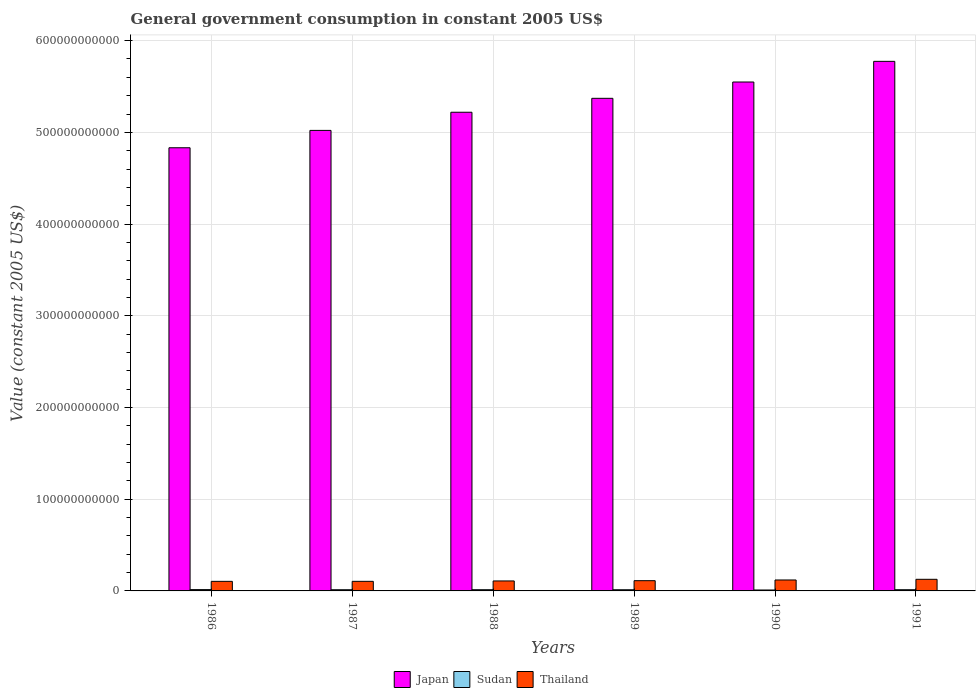How many different coloured bars are there?
Keep it short and to the point. 3. Are the number of bars per tick equal to the number of legend labels?
Your answer should be compact. Yes. How many bars are there on the 1st tick from the right?
Your answer should be compact. 3. In how many cases, is the number of bars for a given year not equal to the number of legend labels?
Ensure brevity in your answer.  0. What is the government conusmption in Thailand in 1987?
Provide a succinct answer. 1.05e+1. Across all years, what is the maximum government conusmption in Sudan?
Your answer should be compact. 1.44e+09. Across all years, what is the minimum government conusmption in Sudan?
Your answer should be very brief. 1.02e+09. In which year was the government conusmption in Thailand minimum?
Provide a succinct answer. 1986. What is the total government conusmption in Japan in the graph?
Your answer should be compact. 3.18e+12. What is the difference between the government conusmption in Sudan in 1987 and that in 1990?
Offer a very short reply. 2.80e+08. What is the difference between the government conusmption in Sudan in 1989 and the government conusmption in Japan in 1991?
Offer a very short reply. -5.76e+11. What is the average government conusmption in Thailand per year?
Provide a short and direct response. 1.13e+1. In the year 1986, what is the difference between the government conusmption in Sudan and government conusmption in Japan?
Provide a succinct answer. -4.82e+11. In how many years, is the government conusmption in Japan greater than 420000000000 US$?
Give a very brief answer. 6. What is the ratio of the government conusmption in Thailand in 1988 to that in 1990?
Your answer should be very brief. 0.91. Is the government conusmption in Japan in 1989 less than that in 1991?
Give a very brief answer. Yes. What is the difference between the highest and the second highest government conusmption in Thailand?
Offer a very short reply. 7.39e+08. What is the difference between the highest and the lowest government conusmption in Japan?
Your response must be concise. 9.42e+1. In how many years, is the government conusmption in Thailand greater than the average government conusmption in Thailand taken over all years?
Your answer should be compact. 2. What does the 3rd bar from the right in 1990 represents?
Make the answer very short. Japan. How many years are there in the graph?
Keep it short and to the point. 6. What is the difference between two consecutive major ticks on the Y-axis?
Provide a short and direct response. 1.00e+11. Are the values on the major ticks of Y-axis written in scientific E-notation?
Provide a short and direct response. No. Does the graph contain any zero values?
Provide a short and direct response. No. Where does the legend appear in the graph?
Provide a succinct answer. Bottom center. How are the legend labels stacked?
Offer a very short reply. Horizontal. What is the title of the graph?
Your answer should be compact. General government consumption in constant 2005 US$. Does "Gabon" appear as one of the legend labels in the graph?
Keep it short and to the point. No. What is the label or title of the Y-axis?
Offer a very short reply. Value (constant 2005 US$). What is the Value (constant 2005 US$) of Japan in 1986?
Your answer should be very brief. 4.83e+11. What is the Value (constant 2005 US$) in Sudan in 1986?
Your answer should be very brief. 1.44e+09. What is the Value (constant 2005 US$) of Thailand in 1986?
Ensure brevity in your answer.  1.04e+1. What is the Value (constant 2005 US$) of Japan in 1987?
Your answer should be very brief. 5.02e+11. What is the Value (constant 2005 US$) in Sudan in 1987?
Provide a succinct answer. 1.30e+09. What is the Value (constant 2005 US$) in Thailand in 1987?
Give a very brief answer. 1.05e+1. What is the Value (constant 2005 US$) in Japan in 1988?
Ensure brevity in your answer.  5.22e+11. What is the Value (constant 2005 US$) in Sudan in 1988?
Offer a very short reply. 1.32e+09. What is the Value (constant 2005 US$) in Thailand in 1988?
Your answer should be very brief. 1.09e+1. What is the Value (constant 2005 US$) of Japan in 1989?
Provide a short and direct response. 5.37e+11. What is the Value (constant 2005 US$) of Sudan in 1989?
Give a very brief answer. 1.29e+09. What is the Value (constant 2005 US$) in Thailand in 1989?
Your answer should be very brief. 1.12e+1. What is the Value (constant 2005 US$) of Japan in 1990?
Ensure brevity in your answer.  5.55e+11. What is the Value (constant 2005 US$) in Sudan in 1990?
Provide a succinct answer. 1.02e+09. What is the Value (constant 2005 US$) of Thailand in 1990?
Make the answer very short. 1.19e+1. What is the Value (constant 2005 US$) in Japan in 1991?
Make the answer very short. 5.77e+11. What is the Value (constant 2005 US$) of Sudan in 1991?
Offer a very short reply. 1.32e+09. What is the Value (constant 2005 US$) of Thailand in 1991?
Make the answer very short. 1.27e+1. Across all years, what is the maximum Value (constant 2005 US$) in Japan?
Provide a short and direct response. 5.77e+11. Across all years, what is the maximum Value (constant 2005 US$) in Sudan?
Provide a short and direct response. 1.44e+09. Across all years, what is the maximum Value (constant 2005 US$) of Thailand?
Make the answer very short. 1.27e+1. Across all years, what is the minimum Value (constant 2005 US$) in Japan?
Provide a short and direct response. 4.83e+11. Across all years, what is the minimum Value (constant 2005 US$) in Sudan?
Make the answer very short. 1.02e+09. Across all years, what is the minimum Value (constant 2005 US$) in Thailand?
Keep it short and to the point. 1.04e+1. What is the total Value (constant 2005 US$) of Japan in the graph?
Make the answer very short. 3.18e+12. What is the total Value (constant 2005 US$) of Sudan in the graph?
Keep it short and to the point. 7.68e+09. What is the total Value (constant 2005 US$) in Thailand in the graph?
Give a very brief answer. 6.75e+1. What is the difference between the Value (constant 2005 US$) in Japan in 1986 and that in 1987?
Your answer should be very brief. -1.89e+1. What is the difference between the Value (constant 2005 US$) of Sudan in 1986 and that in 1987?
Make the answer very short. 1.37e+08. What is the difference between the Value (constant 2005 US$) in Thailand in 1986 and that in 1987?
Your response must be concise. -2.98e+07. What is the difference between the Value (constant 2005 US$) of Japan in 1986 and that in 1988?
Your answer should be very brief. -3.87e+1. What is the difference between the Value (constant 2005 US$) in Sudan in 1986 and that in 1988?
Your response must be concise. 1.16e+08. What is the difference between the Value (constant 2005 US$) in Thailand in 1986 and that in 1988?
Offer a terse response. -4.51e+08. What is the difference between the Value (constant 2005 US$) of Japan in 1986 and that in 1989?
Keep it short and to the point. -5.39e+1. What is the difference between the Value (constant 2005 US$) in Sudan in 1986 and that in 1989?
Give a very brief answer. 1.50e+08. What is the difference between the Value (constant 2005 US$) in Thailand in 1986 and that in 1989?
Ensure brevity in your answer.  -7.37e+08. What is the difference between the Value (constant 2005 US$) in Japan in 1986 and that in 1990?
Make the answer very short. -7.17e+1. What is the difference between the Value (constant 2005 US$) in Sudan in 1986 and that in 1990?
Offer a terse response. 4.17e+08. What is the difference between the Value (constant 2005 US$) in Thailand in 1986 and that in 1990?
Provide a succinct answer. -1.51e+09. What is the difference between the Value (constant 2005 US$) in Japan in 1986 and that in 1991?
Your answer should be very brief. -9.42e+1. What is the difference between the Value (constant 2005 US$) of Sudan in 1986 and that in 1991?
Ensure brevity in your answer.  1.16e+08. What is the difference between the Value (constant 2005 US$) of Thailand in 1986 and that in 1991?
Your response must be concise. -2.25e+09. What is the difference between the Value (constant 2005 US$) of Japan in 1987 and that in 1988?
Your response must be concise. -1.98e+1. What is the difference between the Value (constant 2005 US$) of Sudan in 1987 and that in 1988?
Give a very brief answer. -2.08e+07. What is the difference between the Value (constant 2005 US$) in Thailand in 1987 and that in 1988?
Give a very brief answer. -4.22e+08. What is the difference between the Value (constant 2005 US$) in Japan in 1987 and that in 1989?
Your answer should be compact. -3.50e+1. What is the difference between the Value (constant 2005 US$) in Sudan in 1987 and that in 1989?
Your answer should be very brief. 1.28e+07. What is the difference between the Value (constant 2005 US$) in Thailand in 1987 and that in 1989?
Your answer should be very brief. -7.07e+08. What is the difference between the Value (constant 2005 US$) in Japan in 1987 and that in 1990?
Provide a succinct answer. -5.28e+1. What is the difference between the Value (constant 2005 US$) in Sudan in 1987 and that in 1990?
Provide a short and direct response. 2.80e+08. What is the difference between the Value (constant 2005 US$) in Thailand in 1987 and that in 1990?
Offer a very short reply. -1.48e+09. What is the difference between the Value (constant 2005 US$) of Japan in 1987 and that in 1991?
Your response must be concise. -7.53e+1. What is the difference between the Value (constant 2005 US$) in Sudan in 1987 and that in 1991?
Offer a very short reply. -2.11e+07. What is the difference between the Value (constant 2005 US$) of Thailand in 1987 and that in 1991?
Your response must be concise. -2.22e+09. What is the difference between the Value (constant 2005 US$) in Japan in 1988 and that in 1989?
Your response must be concise. -1.52e+1. What is the difference between the Value (constant 2005 US$) of Sudan in 1988 and that in 1989?
Offer a very short reply. 3.36e+07. What is the difference between the Value (constant 2005 US$) of Thailand in 1988 and that in 1989?
Make the answer very short. -2.85e+08. What is the difference between the Value (constant 2005 US$) in Japan in 1988 and that in 1990?
Provide a short and direct response. -3.30e+1. What is the difference between the Value (constant 2005 US$) of Sudan in 1988 and that in 1990?
Your response must be concise. 3.01e+08. What is the difference between the Value (constant 2005 US$) of Thailand in 1988 and that in 1990?
Offer a terse response. -1.06e+09. What is the difference between the Value (constant 2005 US$) in Japan in 1988 and that in 1991?
Your response must be concise. -5.55e+1. What is the difference between the Value (constant 2005 US$) in Sudan in 1988 and that in 1991?
Your answer should be compact. -2.87e+05. What is the difference between the Value (constant 2005 US$) in Thailand in 1988 and that in 1991?
Your response must be concise. -1.80e+09. What is the difference between the Value (constant 2005 US$) of Japan in 1989 and that in 1990?
Your answer should be very brief. -1.78e+1. What is the difference between the Value (constant 2005 US$) in Sudan in 1989 and that in 1990?
Keep it short and to the point. 2.67e+08. What is the difference between the Value (constant 2005 US$) in Thailand in 1989 and that in 1990?
Make the answer very short. -7.72e+08. What is the difference between the Value (constant 2005 US$) in Japan in 1989 and that in 1991?
Keep it short and to the point. -4.03e+1. What is the difference between the Value (constant 2005 US$) in Sudan in 1989 and that in 1991?
Provide a short and direct response. -3.38e+07. What is the difference between the Value (constant 2005 US$) in Thailand in 1989 and that in 1991?
Your response must be concise. -1.51e+09. What is the difference between the Value (constant 2005 US$) of Japan in 1990 and that in 1991?
Your answer should be compact. -2.25e+1. What is the difference between the Value (constant 2005 US$) in Sudan in 1990 and that in 1991?
Provide a short and direct response. -3.01e+08. What is the difference between the Value (constant 2005 US$) in Thailand in 1990 and that in 1991?
Your answer should be very brief. -7.39e+08. What is the difference between the Value (constant 2005 US$) in Japan in 1986 and the Value (constant 2005 US$) in Sudan in 1987?
Keep it short and to the point. 4.82e+11. What is the difference between the Value (constant 2005 US$) of Japan in 1986 and the Value (constant 2005 US$) of Thailand in 1987?
Ensure brevity in your answer.  4.73e+11. What is the difference between the Value (constant 2005 US$) of Sudan in 1986 and the Value (constant 2005 US$) of Thailand in 1987?
Keep it short and to the point. -9.02e+09. What is the difference between the Value (constant 2005 US$) of Japan in 1986 and the Value (constant 2005 US$) of Sudan in 1988?
Give a very brief answer. 4.82e+11. What is the difference between the Value (constant 2005 US$) in Japan in 1986 and the Value (constant 2005 US$) in Thailand in 1988?
Provide a succinct answer. 4.72e+11. What is the difference between the Value (constant 2005 US$) in Sudan in 1986 and the Value (constant 2005 US$) in Thailand in 1988?
Offer a very short reply. -9.44e+09. What is the difference between the Value (constant 2005 US$) of Japan in 1986 and the Value (constant 2005 US$) of Sudan in 1989?
Keep it short and to the point. 4.82e+11. What is the difference between the Value (constant 2005 US$) in Japan in 1986 and the Value (constant 2005 US$) in Thailand in 1989?
Make the answer very short. 4.72e+11. What is the difference between the Value (constant 2005 US$) in Sudan in 1986 and the Value (constant 2005 US$) in Thailand in 1989?
Make the answer very short. -9.73e+09. What is the difference between the Value (constant 2005 US$) in Japan in 1986 and the Value (constant 2005 US$) in Sudan in 1990?
Offer a terse response. 4.82e+11. What is the difference between the Value (constant 2005 US$) in Japan in 1986 and the Value (constant 2005 US$) in Thailand in 1990?
Your response must be concise. 4.71e+11. What is the difference between the Value (constant 2005 US$) in Sudan in 1986 and the Value (constant 2005 US$) in Thailand in 1990?
Make the answer very short. -1.05e+1. What is the difference between the Value (constant 2005 US$) of Japan in 1986 and the Value (constant 2005 US$) of Sudan in 1991?
Keep it short and to the point. 4.82e+11. What is the difference between the Value (constant 2005 US$) of Japan in 1986 and the Value (constant 2005 US$) of Thailand in 1991?
Offer a terse response. 4.71e+11. What is the difference between the Value (constant 2005 US$) of Sudan in 1986 and the Value (constant 2005 US$) of Thailand in 1991?
Your response must be concise. -1.12e+1. What is the difference between the Value (constant 2005 US$) of Japan in 1987 and the Value (constant 2005 US$) of Sudan in 1988?
Ensure brevity in your answer.  5.01e+11. What is the difference between the Value (constant 2005 US$) in Japan in 1987 and the Value (constant 2005 US$) in Thailand in 1988?
Ensure brevity in your answer.  4.91e+11. What is the difference between the Value (constant 2005 US$) of Sudan in 1987 and the Value (constant 2005 US$) of Thailand in 1988?
Give a very brief answer. -9.58e+09. What is the difference between the Value (constant 2005 US$) of Japan in 1987 and the Value (constant 2005 US$) of Sudan in 1989?
Ensure brevity in your answer.  5.01e+11. What is the difference between the Value (constant 2005 US$) in Japan in 1987 and the Value (constant 2005 US$) in Thailand in 1989?
Offer a terse response. 4.91e+11. What is the difference between the Value (constant 2005 US$) in Sudan in 1987 and the Value (constant 2005 US$) in Thailand in 1989?
Your answer should be compact. -9.86e+09. What is the difference between the Value (constant 2005 US$) in Japan in 1987 and the Value (constant 2005 US$) in Sudan in 1990?
Provide a succinct answer. 5.01e+11. What is the difference between the Value (constant 2005 US$) of Japan in 1987 and the Value (constant 2005 US$) of Thailand in 1990?
Make the answer very short. 4.90e+11. What is the difference between the Value (constant 2005 US$) of Sudan in 1987 and the Value (constant 2005 US$) of Thailand in 1990?
Your answer should be compact. -1.06e+1. What is the difference between the Value (constant 2005 US$) of Japan in 1987 and the Value (constant 2005 US$) of Sudan in 1991?
Offer a terse response. 5.01e+11. What is the difference between the Value (constant 2005 US$) in Japan in 1987 and the Value (constant 2005 US$) in Thailand in 1991?
Provide a short and direct response. 4.89e+11. What is the difference between the Value (constant 2005 US$) of Sudan in 1987 and the Value (constant 2005 US$) of Thailand in 1991?
Provide a succinct answer. -1.14e+1. What is the difference between the Value (constant 2005 US$) in Japan in 1988 and the Value (constant 2005 US$) in Sudan in 1989?
Give a very brief answer. 5.21e+11. What is the difference between the Value (constant 2005 US$) in Japan in 1988 and the Value (constant 2005 US$) in Thailand in 1989?
Provide a succinct answer. 5.11e+11. What is the difference between the Value (constant 2005 US$) in Sudan in 1988 and the Value (constant 2005 US$) in Thailand in 1989?
Your answer should be very brief. -9.84e+09. What is the difference between the Value (constant 2005 US$) of Japan in 1988 and the Value (constant 2005 US$) of Sudan in 1990?
Make the answer very short. 5.21e+11. What is the difference between the Value (constant 2005 US$) in Japan in 1988 and the Value (constant 2005 US$) in Thailand in 1990?
Make the answer very short. 5.10e+11. What is the difference between the Value (constant 2005 US$) in Sudan in 1988 and the Value (constant 2005 US$) in Thailand in 1990?
Keep it short and to the point. -1.06e+1. What is the difference between the Value (constant 2005 US$) of Japan in 1988 and the Value (constant 2005 US$) of Sudan in 1991?
Give a very brief answer. 5.21e+11. What is the difference between the Value (constant 2005 US$) of Japan in 1988 and the Value (constant 2005 US$) of Thailand in 1991?
Provide a succinct answer. 5.09e+11. What is the difference between the Value (constant 2005 US$) of Sudan in 1988 and the Value (constant 2005 US$) of Thailand in 1991?
Offer a terse response. -1.14e+1. What is the difference between the Value (constant 2005 US$) of Japan in 1989 and the Value (constant 2005 US$) of Sudan in 1990?
Provide a succinct answer. 5.36e+11. What is the difference between the Value (constant 2005 US$) in Japan in 1989 and the Value (constant 2005 US$) in Thailand in 1990?
Keep it short and to the point. 5.25e+11. What is the difference between the Value (constant 2005 US$) in Sudan in 1989 and the Value (constant 2005 US$) in Thailand in 1990?
Keep it short and to the point. -1.06e+1. What is the difference between the Value (constant 2005 US$) in Japan in 1989 and the Value (constant 2005 US$) in Sudan in 1991?
Your answer should be compact. 5.36e+11. What is the difference between the Value (constant 2005 US$) in Japan in 1989 and the Value (constant 2005 US$) in Thailand in 1991?
Ensure brevity in your answer.  5.24e+11. What is the difference between the Value (constant 2005 US$) of Sudan in 1989 and the Value (constant 2005 US$) of Thailand in 1991?
Offer a terse response. -1.14e+1. What is the difference between the Value (constant 2005 US$) of Japan in 1990 and the Value (constant 2005 US$) of Sudan in 1991?
Make the answer very short. 5.54e+11. What is the difference between the Value (constant 2005 US$) of Japan in 1990 and the Value (constant 2005 US$) of Thailand in 1991?
Provide a short and direct response. 5.42e+11. What is the difference between the Value (constant 2005 US$) in Sudan in 1990 and the Value (constant 2005 US$) in Thailand in 1991?
Keep it short and to the point. -1.17e+1. What is the average Value (constant 2005 US$) in Japan per year?
Your answer should be compact. 5.29e+11. What is the average Value (constant 2005 US$) in Sudan per year?
Your response must be concise. 1.28e+09. What is the average Value (constant 2005 US$) of Thailand per year?
Keep it short and to the point. 1.13e+1. In the year 1986, what is the difference between the Value (constant 2005 US$) of Japan and Value (constant 2005 US$) of Sudan?
Keep it short and to the point. 4.82e+11. In the year 1986, what is the difference between the Value (constant 2005 US$) of Japan and Value (constant 2005 US$) of Thailand?
Your answer should be compact. 4.73e+11. In the year 1986, what is the difference between the Value (constant 2005 US$) in Sudan and Value (constant 2005 US$) in Thailand?
Give a very brief answer. -8.99e+09. In the year 1987, what is the difference between the Value (constant 2005 US$) in Japan and Value (constant 2005 US$) in Sudan?
Make the answer very short. 5.01e+11. In the year 1987, what is the difference between the Value (constant 2005 US$) in Japan and Value (constant 2005 US$) in Thailand?
Provide a short and direct response. 4.92e+11. In the year 1987, what is the difference between the Value (constant 2005 US$) in Sudan and Value (constant 2005 US$) in Thailand?
Give a very brief answer. -9.16e+09. In the year 1988, what is the difference between the Value (constant 2005 US$) in Japan and Value (constant 2005 US$) in Sudan?
Your answer should be very brief. 5.21e+11. In the year 1988, what is the difference between the Value (constant 2005 US$) of Japan and Value (constant 2005 US$) of Thailand?
Ensure brevity in your answer.  5.11e+11. In the year 1988, what is the difference between the Value (constant 2005 US$) in Sudan and Value (constant 2005 US$) in Thailand?
Provide a succinct answer. -9.56e+09. In the year 1989, what is the difference between the Value (constant 2005 US$) in Japan and Value (constant 2005 US$) in Sudan?
Keep it short and to the point. 5.36e+11. In the year 1989, what is the difference between the Value (constant 2005 US$) in Japan and Value (constant 2005 US$) in Thailand?
Keep it short and to the point. 5.26e+11. In the year 1989, what is the difference between the Value (constant 2005 US$) in Sudan and Value (constant 2005 US$) in Thailand?
Offer a terse response. -9.88e+09. In the year 1990, what is the difference between the Value (constant 2005 US$) in Japan and Value (constant 2005 US$) in Sudan?
Provide a succinct answer. 5.54e+11. In the year 1990, what is the difference between the Value (constant 2005 US$) of Japan and Value (constant 2005 US$) of Thailand?
Keep it short and to the point. 5.43e+11. In the year 1990, what is the difference between the Value (constant 2005 US$) of Sudan and Value (constant 2005 US$) of Thailand?
Make the answer very short. -1.09e+1. In the year 1991, what is the difference between the Value (constant 2005 US$) of Japan and Value (constant 2005 US$) of Sudan?
Your answer should be very brief. 5.76e+11. In the year 1991, what is the difference between the Value (constant 2005 US$) in Japan and Value (constant 2005 US$) in Thailand?
Ensure brevity in your answer.  5.65e+11. In the year 1991, what is the difference between the Value (constant 2005 US$) of Sudan and Value (constant 2005 US$) of Thailand?
Provide a short and direct response. -1.14e+1. What is the ratio of the Value (constant 2005 US$) in Japan in 1986 to that in 1987?
Provide a succinct answer. 0.96. What is the ratio of the Value (constant 2005 US$) of Sudan in 1986 to that in 1987?
Make the answer very short. 1.11. What is the ratio of the Value (constant 2005 US$) in Japan in 1986 to that in 1988?
Provide a short and direct response. 0.93. What is the ratio of the Value (constant 2005 US$) of Sudan in 1986 to that in 1988?
Keep it short and to the point. 1.09. What is the ratio of the Value (constant 2005 US$) of Thailand in 1986 to that in 1988?
Offer a very short reply. 0.96. What is the ratio of the Value (constant 2005 US$) of Japan in 1986 to that in 1989?
Provide a short and direct response. 0.9. What is the ratio of the Value (constant 2005 US$) of Sudan in 1986 to that in 1989?
Give a very brief answer. 1.12. What is the ratio of the Value (constant 2005 US$) in Thailand in 1986 to that in 1989?
Keep it short and to the point. 0.93. What is the ratio of the Value (constant 2005 US$) in Japan in 1986 to that in 1990?
Make the answer very short. 0.87. What is the ratio of the Value (constant 2005 US$) of Sudan in 1986 to that in 1990?
Provide a short and direct response. 1.41. What is the ratio of the Value (constant 2005 US$) in Thailand in 1986 to that in 1990?
Give a very brief answer. 0.87. What is the ratio of the Value (constant 2005 US$) in Japan in 1986 to that in 1991?
Provide a succinct answer. 0.84. What is the ratio of the Value (constant 2005 US$) of Sudan in 1986 to that in 1991?
Make the answer very short. 1.09. What is the ratio of the Value (constant 2005 US$) in Thailand in 1986 to that in 1991?
Provide a succinct answer. 0.82. What is the ratio of the Value (constant 2005 US$) in Japan in 1987 to that in 1988?
Your answer should be compact. 0.96. What is the ratio of the Value (constant 2005 US$) of Sudan in 1987 to that in 1988?
Provide a succinct answer. 0.98. What is the ratio of the Value (constant 2005 US$) in Thailand in 1987 to that in 1988?
Your answer should be very brief. 0.96. What is the ratio of the Value (constant 2005 US$) in Japan in 1987 to that in 1989?
Your answer should be compact. 0.93. What is the ratio of the Value (constant 2005 US$) of Sudan in 1987 to that in 1989?
Give a very brief answer. 1.01. What is the ratio of the Value (constant 2005 US$) in Thailand in 1987 to that in 1989?
Make the answer very short. 0.94. What is the ratio of the Value (constant 2005 US$) of Japan in 1987 to that in 1990?
Your answer should be compact. 0.9. What is the ratio of the Value (constant 2005 US$) of Sudan in 1987 to that in 1990?
Your answer should be very brief. 1.27. What is the ratio of the Value (constant 2005 US$) in Thailand in 1987 to that in 1990?
Offer a very short reply. 0.88. What is the ratio of the Value (constant 2005 US$) in Japan in 1987 to that in 1991?
Offer a very short reply. 0.87. What is the ratio of the Value (constant 2005 US$) of Thailand in 1987 to that in 1991?
Provide a short and direct response. 0.82. What is the ratio of the Value (constant 2005 US$) of Japan in 1988 to that in 1989?
Provide a short and direct response. 0.97. What is the ratio of the Value (constant 2005 US$) of Sudan in 1988 to that in 1989?
Provide a short and direct response. 1.03. What is the ratio of the Value (constant 2005 US$) in Thailand in 1988 to that in 1989?
Ensure brevity in your answer.  0.97. What is the ratio of the Value (constant 2005 US$) in Japan in 1988 to that in 1990?
Provide a short and direct response. 0.94. What is the ratio of the Value (constant 2005 US$) of Sudan in 1988 to that in 1990?
Your answer should be very brief. 1.3. What is the ratio of the Value (constant 2005 US$) in Thailand in 1988 to that in 1990?
Your answer should be compact. 0.91. What is the ratio of the Value (constant 2005 US$) of Japan in 1988 to that in 1991?
Provide a short and direct response. 0.9. What is the ratio of the Value (constant 2005 US$) in Sudan in 1988 to that in 1991?
Provide a succinct answer. 1. What is the ratio of the Value (constant 2005 US$) of Thailand in 1988 to that in 1991?
Your answer should be compact. 0.86. What is the ratio of the Value (constant 2005 US$) of Japan in 1989 to that in 1990?
Provide a succinct answer. 0.97. What is the ratio of the Value (constant 2005 US$) in Sudan in 1989 to that in 1990?
Provide a short and direct response. 1.26. What is the ratio of the Value (constant 2005 US$) of Thailand in 1989 to that in 1990?
Keep it short and to the point. 0.94. What is the ratio of the Value (constant 2005 US$) in Japan in 1989 to that in 1991?
Keep it short and to the point. 0.93. What is the ratio of the Value (constant 2005 US$) in Sudan in 1989 to that in 1991?
Your answer should be very brief. 0.97. What is the ratio of the Value (constant 2005 US$) in Thailand in 1989 to that in 1991?
Provide a succinct answer. 0.88. What is the ratio of the Value (constant 2005 US$) of Sudan in 1990 to that in 1991?
Your response must be concise. 0.77. What is the ratio of the Value (constant 2005 US$) in Thailand in 1990 to that in 1991?
Give a very brief answer. 0.94. What is the difference between the highest and the second highest Value (constant 2005 US$) of Japan?
Offer a very short reply. 2.25e+1. What is the difference between the highest and the second highest Value (constant 2005 US$) in Sudan?
Your response must be concise. 1.16e+08. What is the difference between the highest and the second highest Value (constant 2005 US$) in Thailand?
Your answer should be compact. 7.39e+08. What is the difference between the highest and the lowest Value (constant 2005 US$) in Japan?
Your answer should be compact. 9.42e+1. What is the difference between the highest and the lowest Value (constant 2005 US$) of Sudan?
Keep it short and to the point. 4.17e+08. What is the difference between the highest and the lowest Value (constant 2005 US$) in Thailand?
Your answer should be compact. 2.25e+09. 